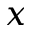Convert formula to latex. <formula><loc_0><loc_0><loc_500><loc_500>x</formula> 